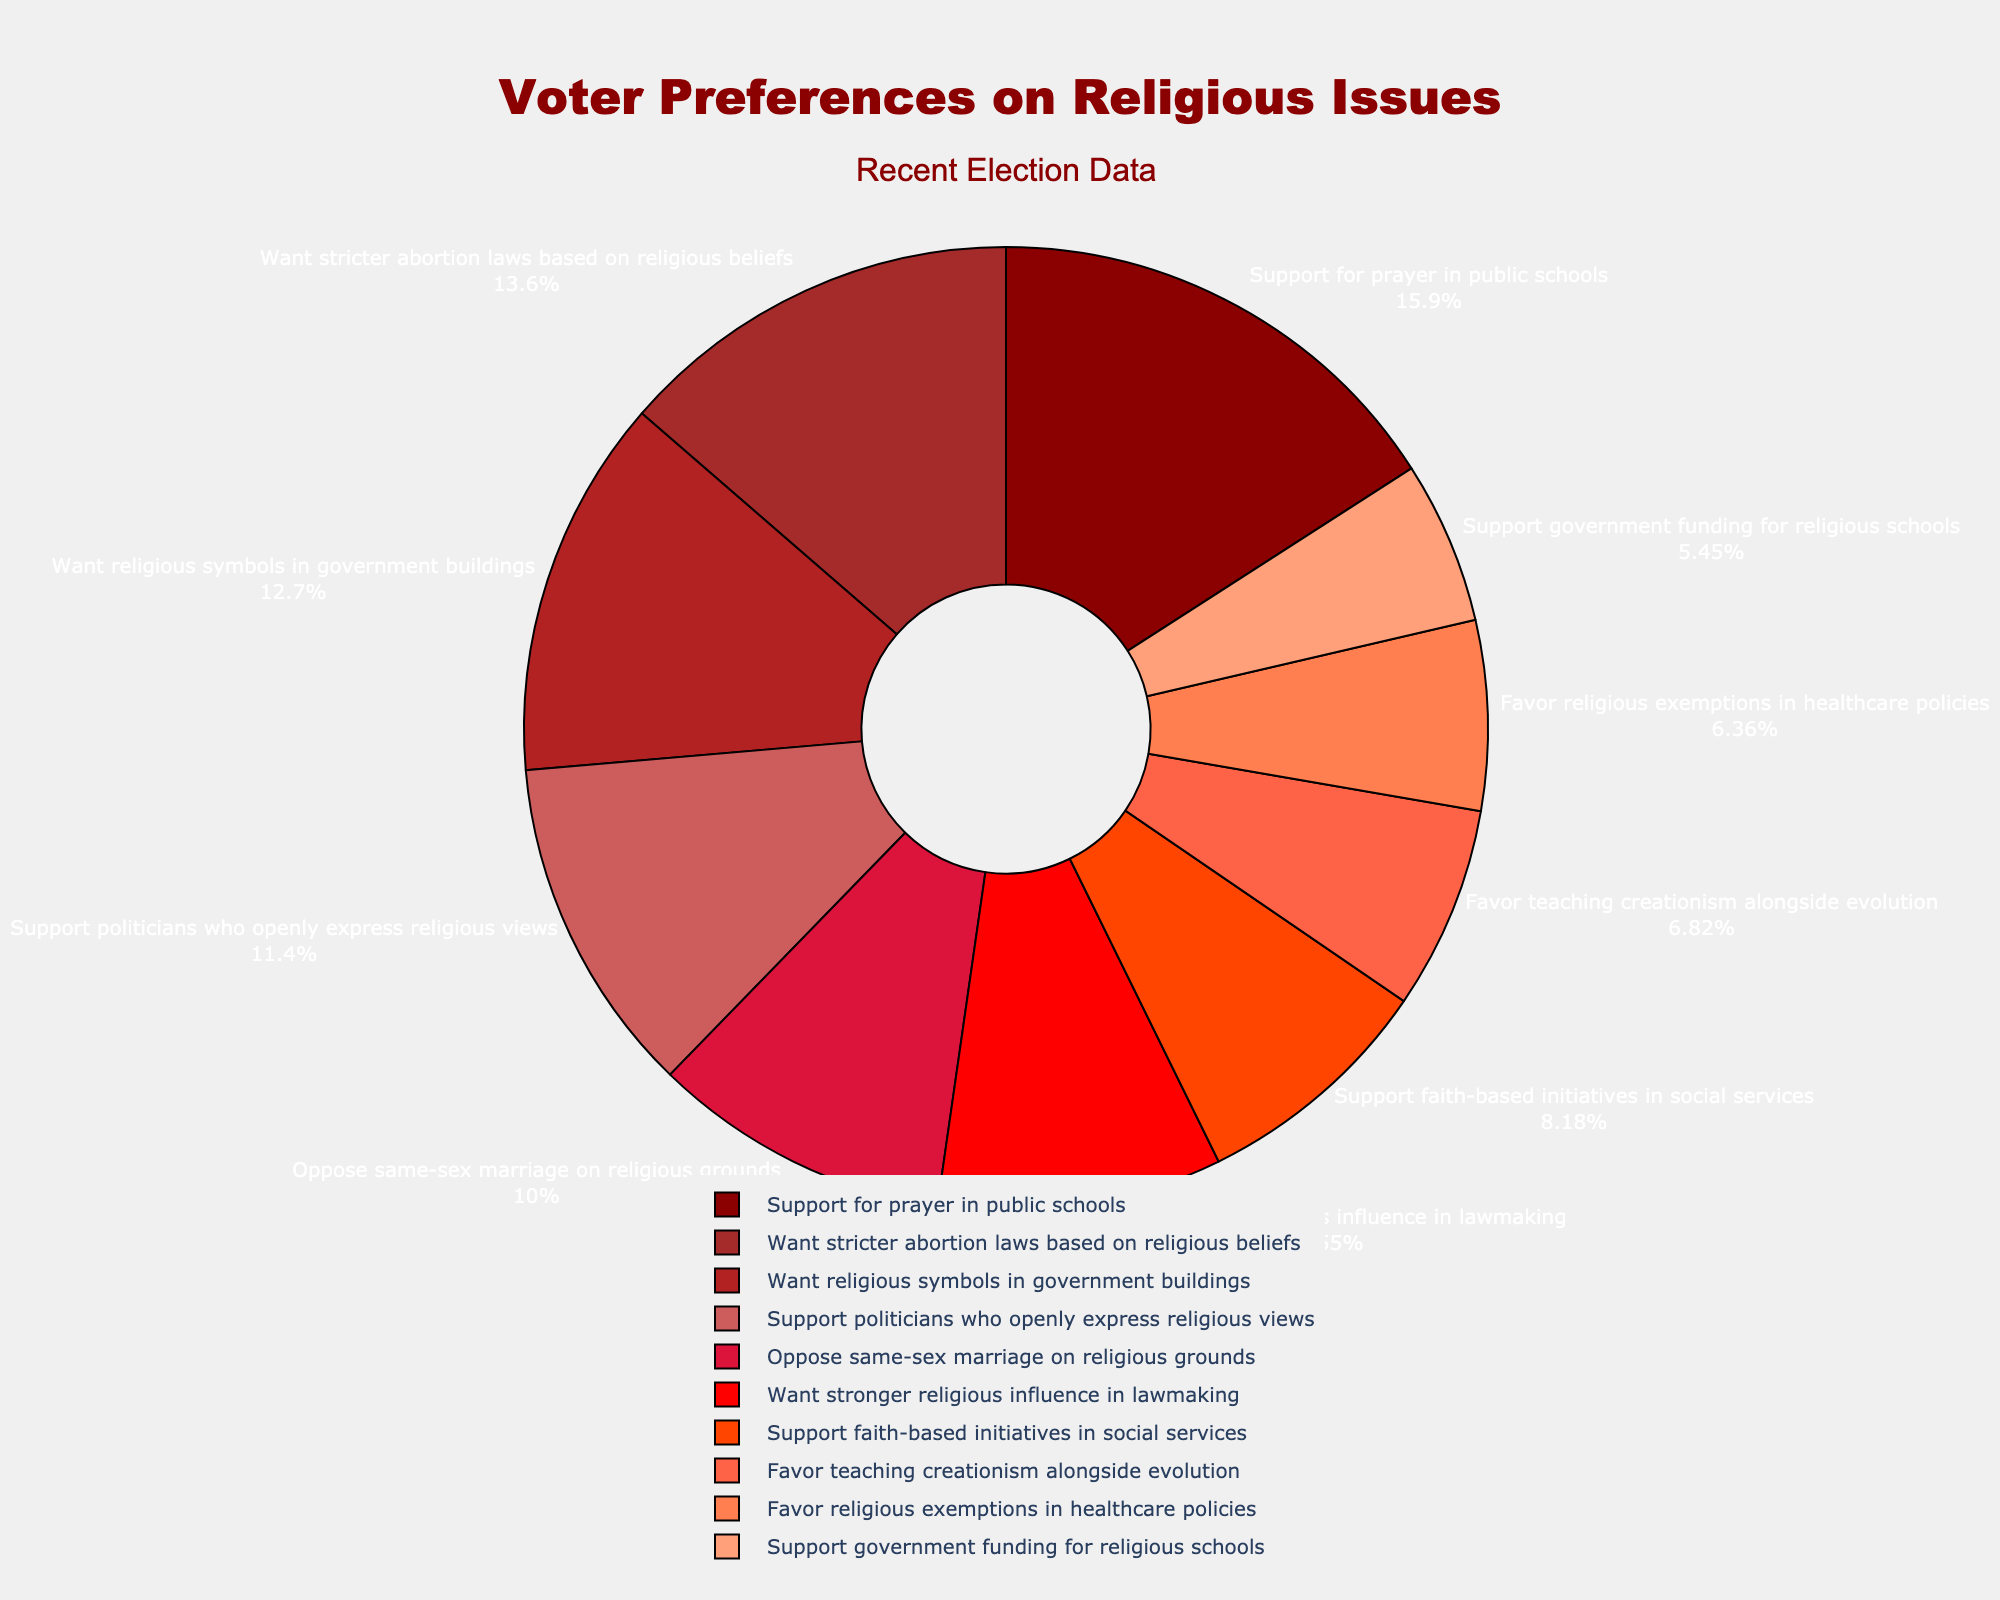Which preference has the highest percentage? The slice for "Support for prayer in public schools" is the largest in the pie chart, indicating it has the highest percentage.
Answer: Support for prayer in public schools What is the difference in percentage between those who want religious symbols in government buildings and those who oppose same-sex marriage on religious grounds? The percentage for "Want religious symbols in government buildings" is 28% and for "Oppose same-sex marriage on religious grounds" is 22%. Thus, the difference is 28 - 22 = 6%.
Answer: 6% What are the combined percentages of those who support faith-based initiatives in social services and those who favor teaching creationism alongside evolution? The percentage for "Support faith-based initiatives in social services" is 18% and for "Favor teaching creationism alongside evolution" is 15%. Adding these gives 18 + 15 = 33%.
Answer: 33% Which preference is depicted in the darkest shade of red? The pie chart uses darker shades of red for higher percentages. "Support for prayer in public schools" is in the darkest shade of red, indicating it has the highest percentage.
Answer: Support for prayer in public schools What percentage of voters support politicians who openly express religious views? The slice labeled "Support politicians who openly express religious views" shows 25%.
Answer: 25% Are there more people who support stricter abortion laws based on religious beliefs or who want stronger religious influence in lawmaking? The percentage for "Want stricter abortion laws based on religious beliefs" is 30%, which is greater than the 21% for "Want stronger religious influence in lawmaking".
Answer: Stricter abortion laws What is the average percentage of the preferences related to religious influence in government (support for prayer in public schools, want religious symbols in government buildings, and want stronger religious influence in lawmaking)? The percentages are 35% for "Support for prayer in public schools", 28% for "Want religious symbols in government buildings", and 21% for "Want stronger religious influence in lawmaking". The average is (35 + 28 + 21) / 3 = 28%.
Answer: 28% Which preferences have percentages lower than 20%? The preferences with percentages lower than 20% are "Support faith-based initiatives in social services" (18%), "Favor teaching creationism alongside evolution" (15%), "Support government funding for religious schools" (12%), and "Favor religious exemptions in healthcare policies" (14%).
Answer: Faith-based initiatives, Teaching creationism, Government funding for religious schools, Religious exemptions in healthcare policies 